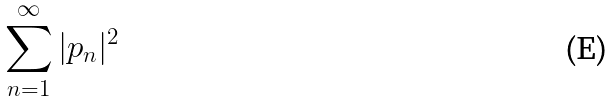<formula> <loc_0><loc_0><loc_500><loc_500>\sum _ { n = 1 } ^ { \infty } | p _ { n } | ^ { 2 }</formula> 